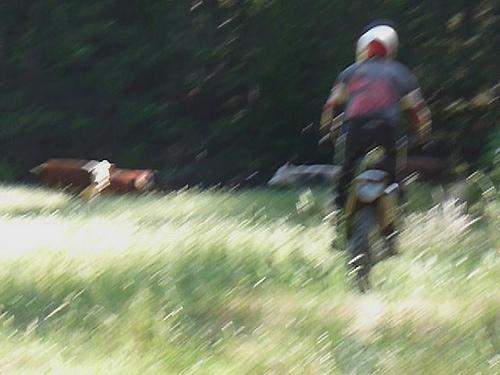Question: when was this photo taken?
Choices:
A. Daytime.
B. Nighttime.
C. Late afternoon.
D. Sunrise.
Answer with the letter. Answer: A Question: what color shirt is the rider wearing?
Choices:
A. Green, silver.
B. Blue, red.
C. Purple, gold.
D. Orange, yellow.
Answer with the letter. Answer: B Question: what color helmet is the rider wearing?
Choices:
A. Gold.
B. SIlver.
C. Red.
D. Black.
Answer with the letter. Answer: B Question: who is standing behind the rider?
Choices:
A. A jockey.
B. A security guard.
C. A woman in evening dress.
D. No one.
Answer with the letter. Answer: D Question: where was this photo taken?
Choices:
A. In the woods.
B. In the field.
C. In the grass.
D. In the hay field.
Answer with the letter. Answer: B 